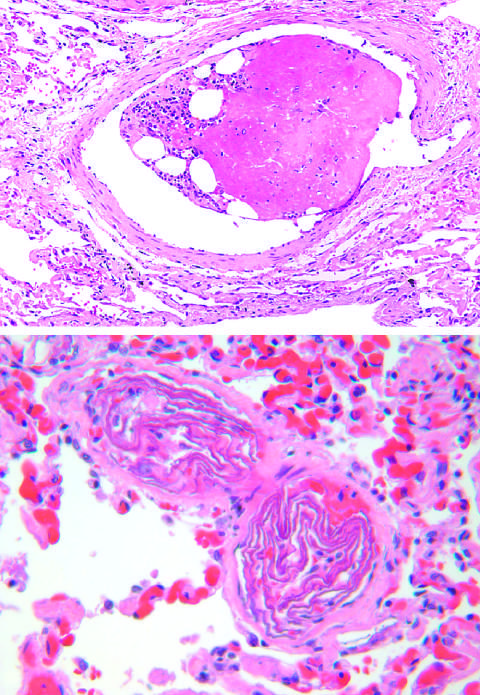re the photomicrographs packed with laminated swirls of fetal squamous cells?
Answer the question using a single word or phrase. No 